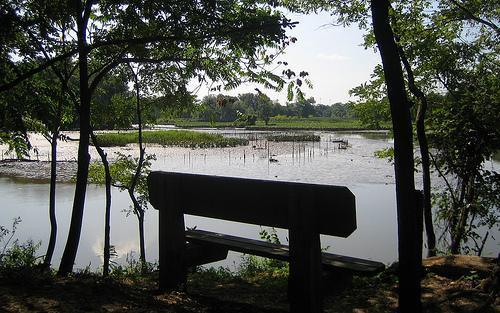How many bench are there?
Give a very brief answer. 1. 